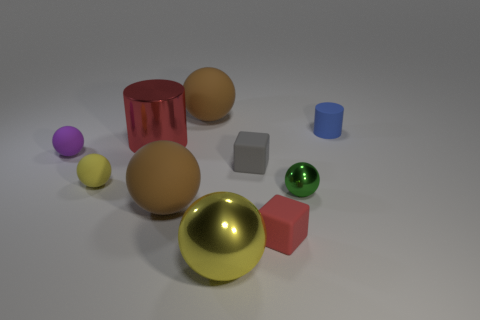There is a brown matte thing that is behind the tiny blue cylinder that is behind the purple rubber object; what is its size?
Your response must be concise. Large. There is a large yellow object that is the same shape as the tiny green shiny object; what is its material?
Offer a very short reply. Metal. How many blue cylinders have the same size as the green shiny thing?
Keep it short and to the point. 1. Is the size of the yellow rubber ball the same as the yellow metallic ball?
Make the answer very short. No. There is a object that is both to the left of the yellow metal sphere and in front of the tiny yellow object; what is its size?
Ensure brevity in your answer.  Large. Are there more things left of the yellow matte object than yellow balls behind the tiny metallic object?
Provide a succinct answer. No. The other tiny matte thing that is the same shape as the red matte object is what color?
Your response must be concise. Gray. There is a small rubber sphere in front of the purple rubber object; is its color the same as the big metallic sphere?
Offer a terse response. Yes. How many big red shiny things are there?
Your response must be concise. 1. Is the material of the ball behind the red shiny cylinder the same as the large red cylinder?
Provide a succinct answer. No. 